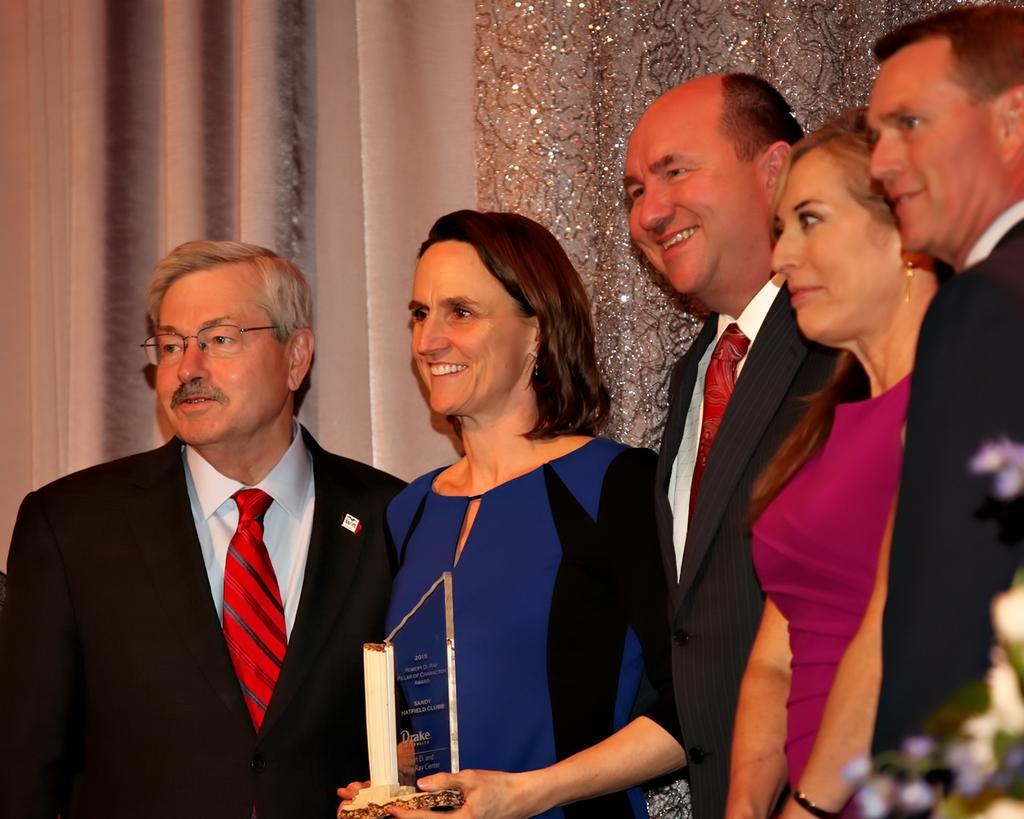Please provide a concise description of this image. In this image there are a few people standing with a smile on their face, behind them there are curtains. 